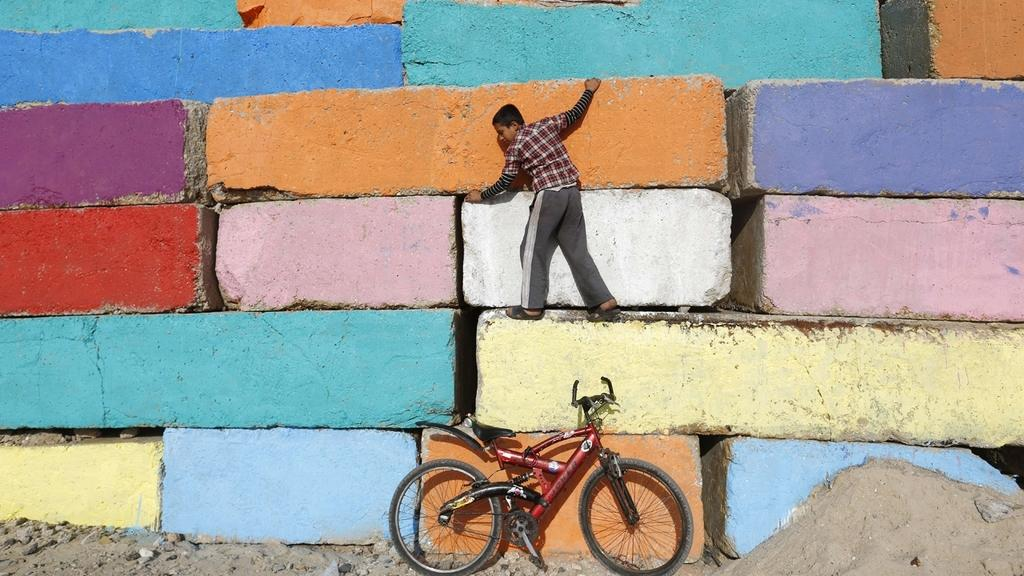What is located in the center of the image? There is a wall in the center of the image. What is on top of the wall? There is a boy on the wall. What can be seen at the bottom of the image? There is a bicycle at the bottom of the image. What type of terrain is visible in the image? There is sand and stones in the image. What type of bomb can be seen in the image? There is no bomb present in the image. Can you describe the snail's shell in the image? There is no snail present in the image. 